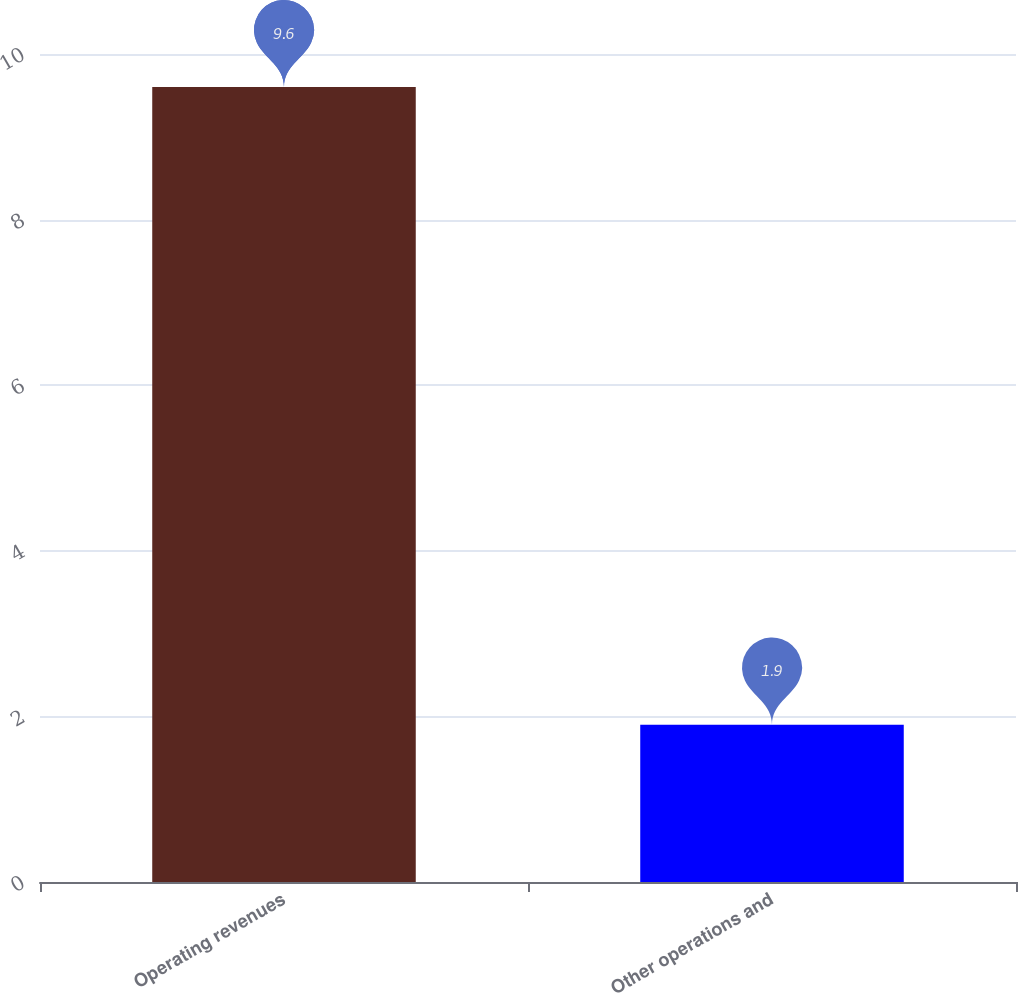Convert chart to OTSL. <chart><loc_0><loc_0><loc_500><loc_500><bar_chart><fcel>Operating revenues<fcel>Other operations and<nl><fcel>9.6<fcel>1.9<nl></chart> 